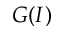<formula> <loc_0><loc_0><loc_500><loc_500>G ( I )</formula> 